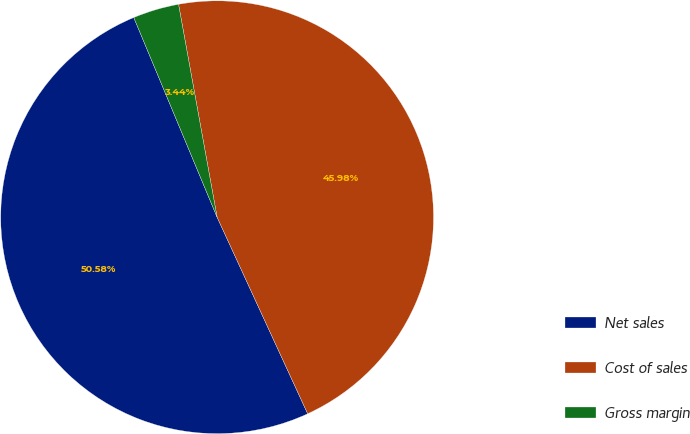Convert chart. <chart><loc_0><loc_0><loc_500><loc_500><pie_chart><fcel>Net sales<fcel>Cost of sales<fcel>Gross margin<nl><fcel>50.58%<fcel>45.98%<fcel>3.44%<nl></chart> 